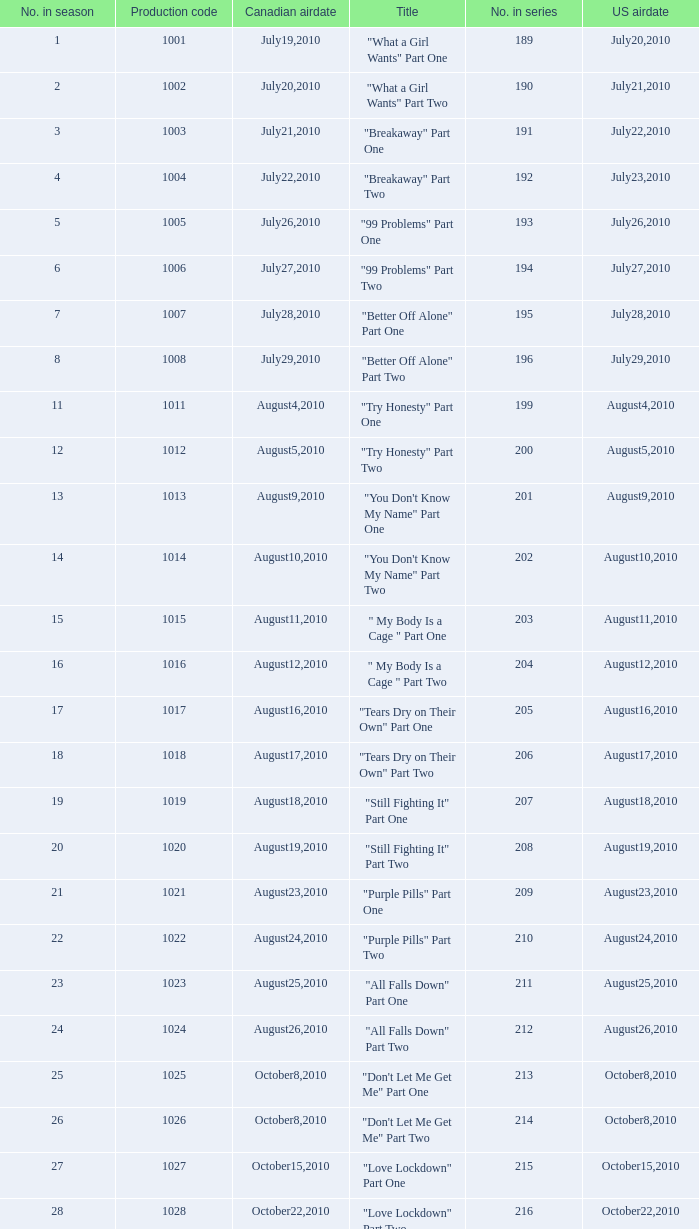How many titles had production code 1040? 1.0. 